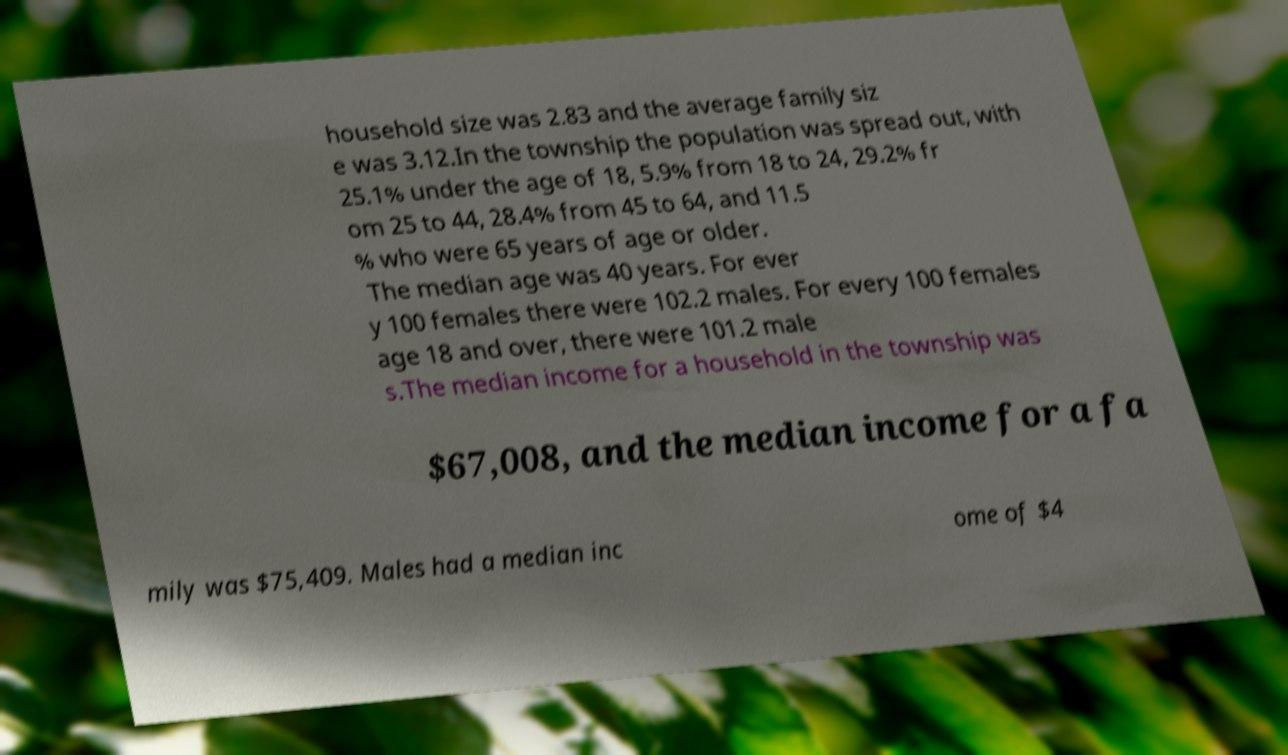What messages or text are displayed in this image? I need them in a readable, typed format. household size was 2.83 and the average family siz e was 3.12.In the township the population was spread out, with 25.1% under the age of 18, 5.9% from 18 to 24, 29.2% fr om 25 to 44, 28.4% from 45 to 64, and 11.5 % who were 65 years of age or older. The median age was 40 years. For ever y 100 females there were 102.2 males. For every 100 females age 18 and over, there were 101.2 male s.The median income for a household in the township was $67,008, and the median income for a fa mily was $75,409. Males had a median inc ome of $4 